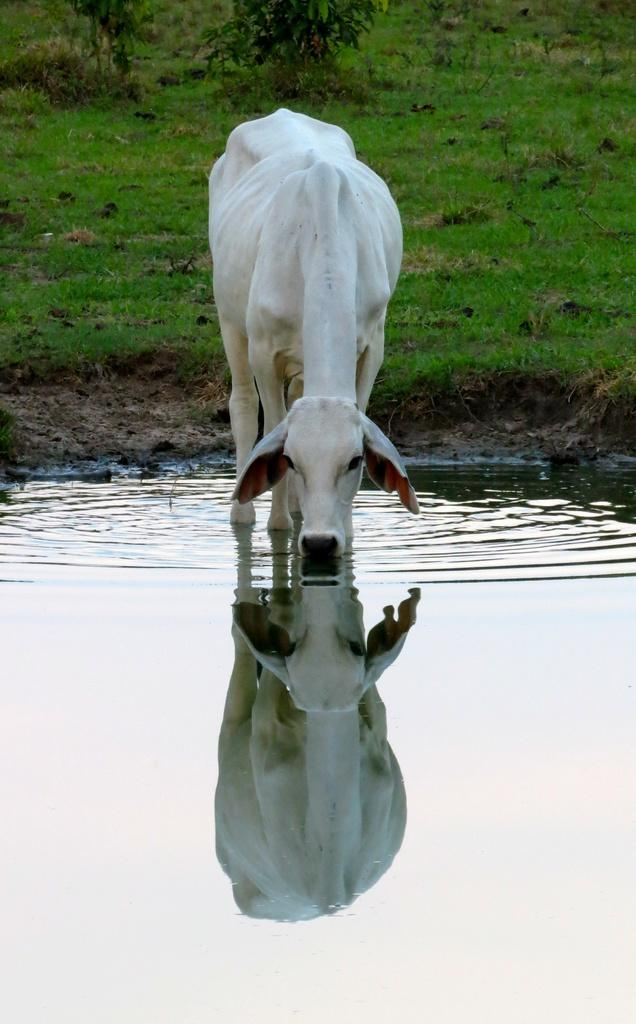What animal is present in the image? There is a cow in the image. What is the cow doing in the image? The cow is drinking water. What type of vegetation can be seen in the image? There are plants visible in the image. What is the surface at the bottom of the image made of? There is grass on the surface at the bottom of the image. What type of celery is being used as a prop in the image? There is no celery present in the image. What event is taking place in the image? The image does not depict a specific event; it shows a cow drinking water in a grassy area. 